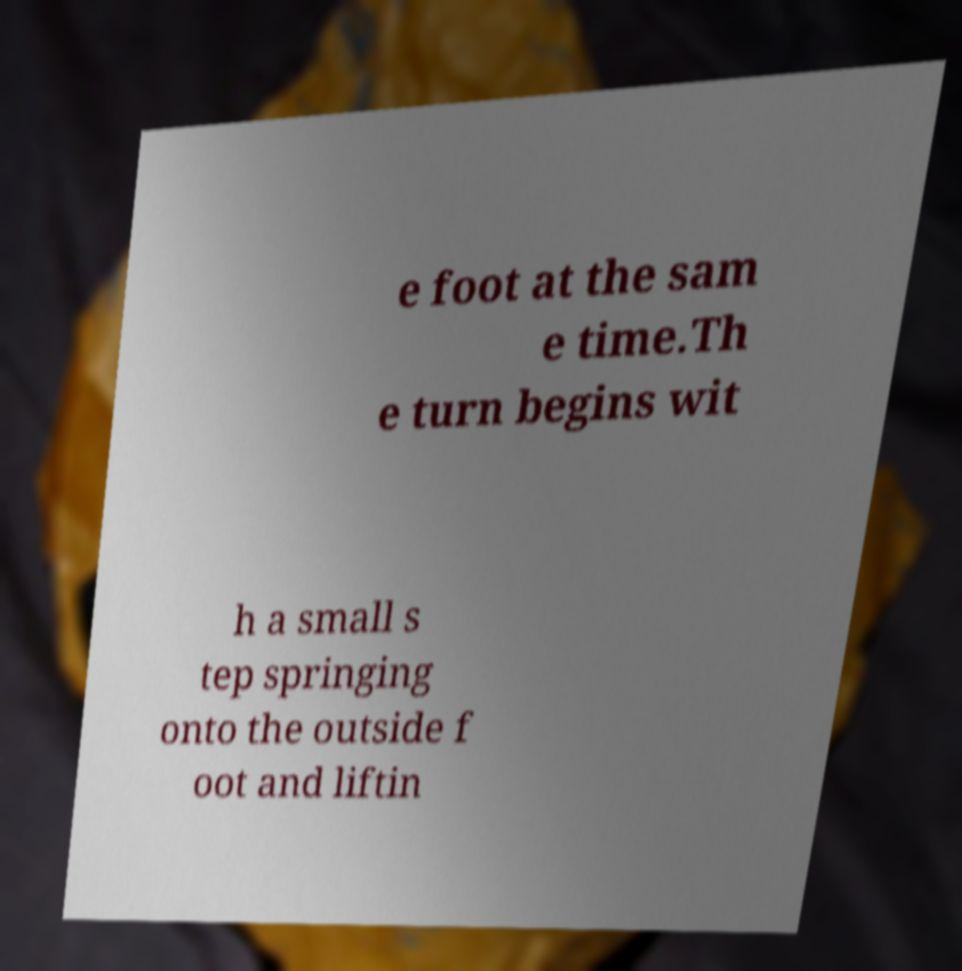What messages or text are displayed in this image? I need them in a readable, typed format. e foot at the sam e time.Th e turn begins wit h a small s tep springing onto the outside f oot and liftin 